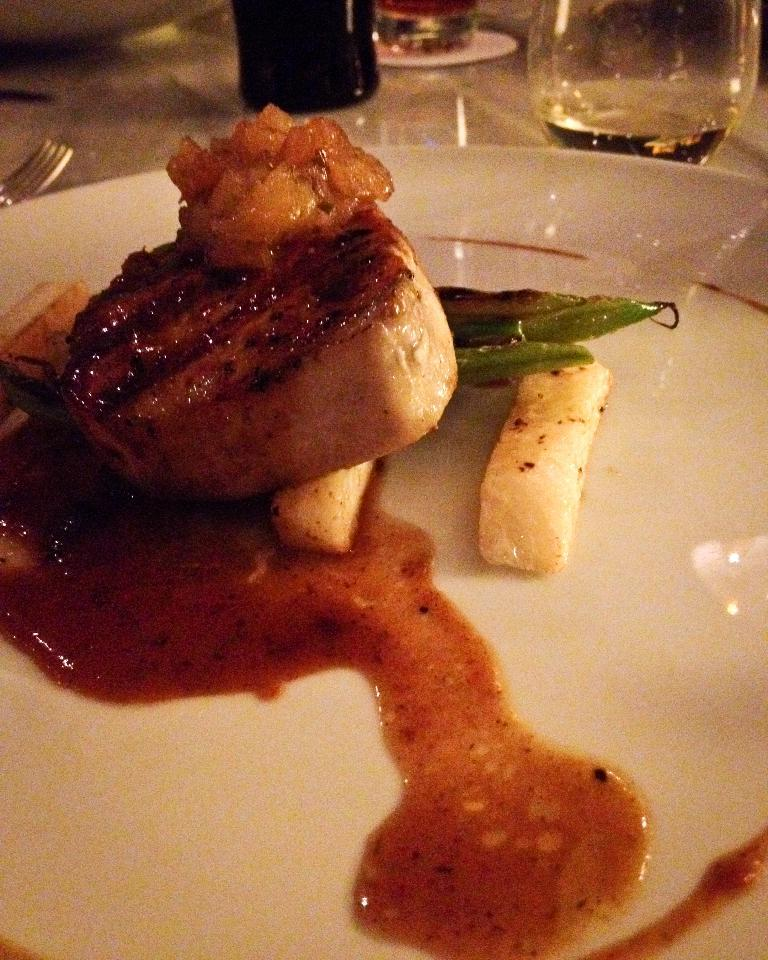What is on the plate that is visible in the image? There is a plate with food items in the image. Where is the plate located in the image? The plate is placed on a table in the image. What utensil is visible in the image? There is a fork in the image. What is the glass used for in the image? The glass is likely used for holding a beverage in the image. What other objects can be seen in the image? There are other objects present in the image, but their specific details are not mentioned in the provided facts. Can you tell me how many times the foot is mentioned in the image? The term "foot" is not mentioned or present in the image. 